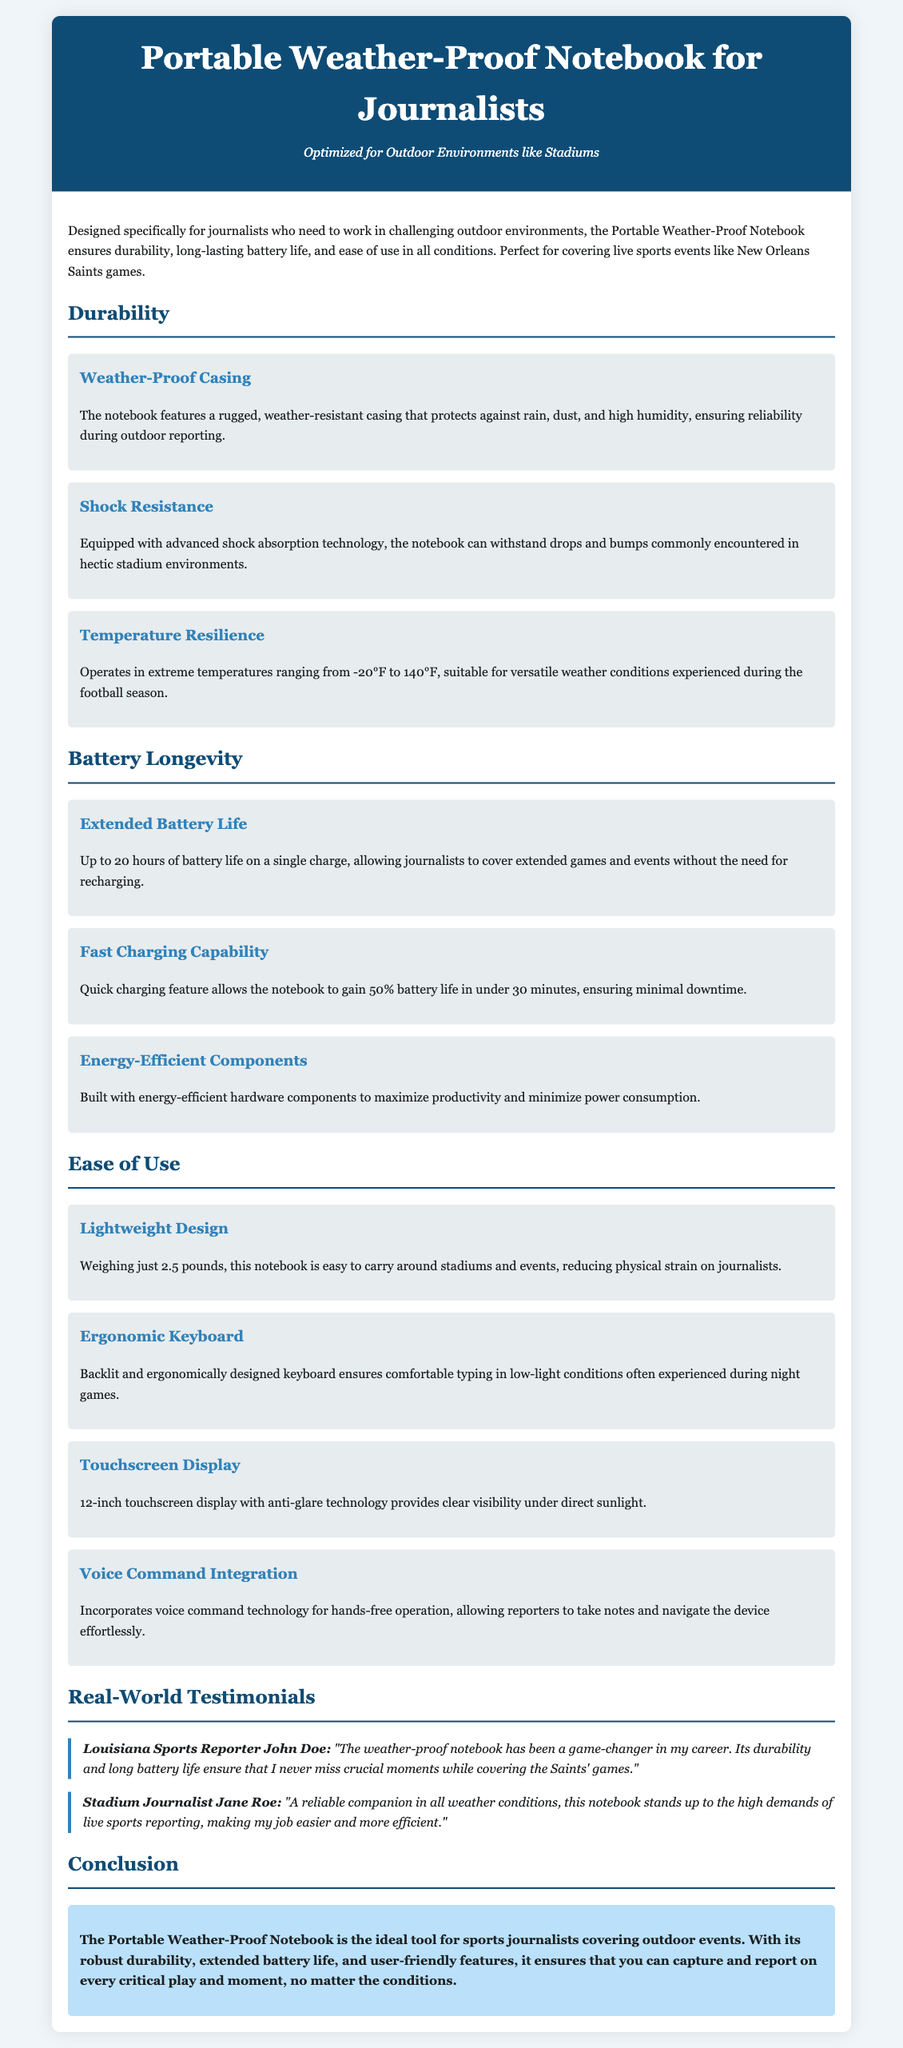What is the weight of the notebook? The weight of the notebook is mentioned in the document as 2.5 pounds.
Answer: 2.5 pounds What temperature range can the notebook operate in? The document specifies that the notebook operates in extreme temperatures ranging from -20°F to 140°F.
Answer: -20°F to 140°F How long is the extended battery life? The extended battery life of the notebook is indicated to be up to 20 hours on a single charge.
Answer: Up to 20 hours What feature allows reporters to use the notebook hands-free? The feature that allows hands-free operation is the voice command technology integrated into the notebook.
Answer: Voice command technology Which journalist praised the notebook in a testimonial? The document includes a testimonial from Louisiana Sports Reporter John Doe.
Answer: John Doe What is the touchscreen size of the notebook? The touchscreen display size is specified in the document as 12 inches.
Answer: 12 inches What unique feature does the notebook have for low-light conditions? The document describes an ergonomic keyboard with backlighting for comfortable typing in low-light conditions.
Answer: Backlit keyboard How quickly can the notebook gain 50% battery life? It is mentioned that the notebook can gain 50% battery life in under 30 minutes.
Answer: Under 30 minutes 